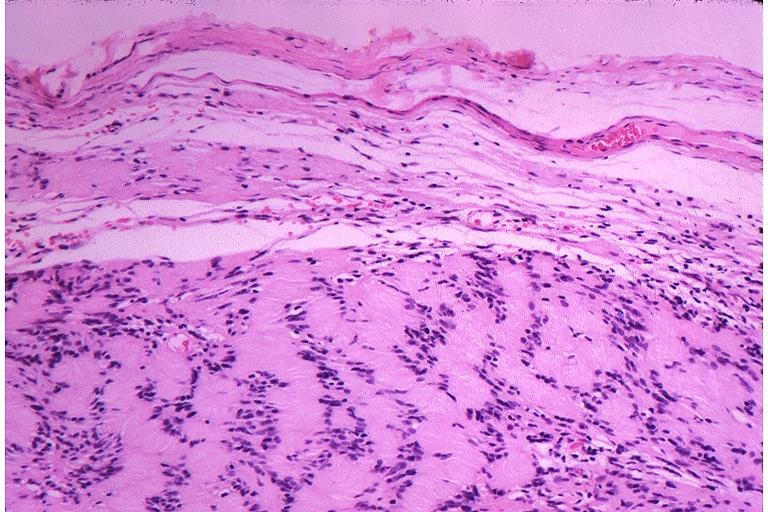s oral present?
Answer the question using a single word or phrase. Yes 